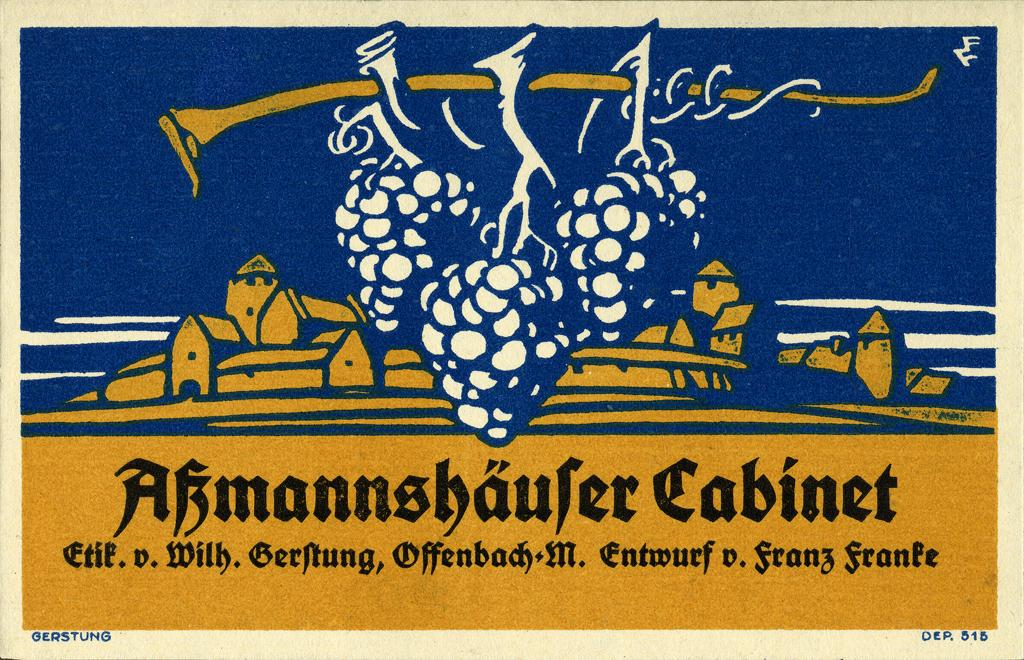<image>
Provide a brief description of the given image. Three bunches of grapes hanging from a branch in front of a village with the caption "Abmannshaufer Cabinet". 